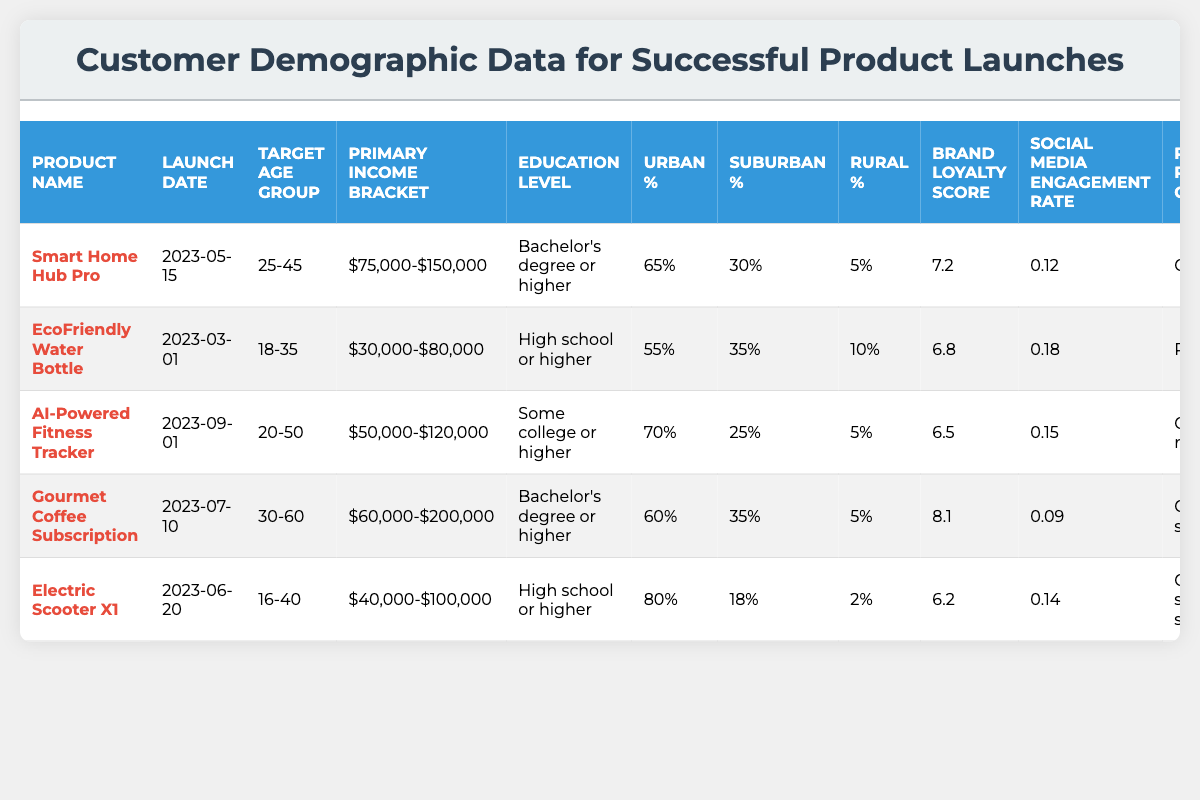What is the target age group for the "Gourmet Coffee Subscription"? The table indicates that the target age group for the "Gourmet Coffee Subscription" is 30-60 years.
Answer: 30-60 Which product has the highest customer lifetime value? By comparing the customer lifetime values listed in the table, the "Gourmet Coffee Subscription" has the highest value at $3200.
Answer: $3200 What is the urban percentage for the "Smart Home Hub Pro"? The table shows that the urban percentage for the "Smart Home Hub Pro" is 65%.
Answer: 65% Is the repeat purchase rate for the "Electric Scooter X1" greater than 0.6? The repeat purchase rate for the "Electric Scooter X1" is 0.55, which is less than 0.6, making the statement false.
Answer: No Calculate the average brand loyalty score for all products. Adding the brand loyalty scores (7.2 + 6.8 + 6.5 + 8.1 + 6.2 = 34.8) and dividing by the number of products (5), the average brand loyalty score is 34.8/5 = 6.96.
Answer: 6.96 What is the preferred purchase channel for the "EcoFriendly Water Bottle"? The table identifies that the preferred purchase channel for the "EcoFriendly Water Bottle" is retail stores.
Answer: Retail stores Which product was launched the earliest and how does its target income bracket compare with others? The "EcoFriendly Water Bottle" was launched on 2023-03-01, with a primary income bracket of $30,000-$80,000. Comparing it with others, its income bracket is the lowest, particularly when looking at the "Gourmet Coffee Subscription" which has a bracket of $60,000-$200,000.
Answer: EcoFriendly Water Bottle; lowest How do the social media engagement rates compare for "AI-Powered Fitness Tracker" and "Gourmet Coffee Subscription"? The social media engagement rate for the "AI-Powered Fitness Tracker" is 0.15, while for the "Gourmet Coffee Subscription" it is 0.09. Thus, the engagement rate for the "AI-Powered Fitness Tracker" is higher.
Answer: AI-Powered Fitness Tracker is higher What percentage of customers for the "Electric Scooter X1" are urban? The table specifies that 80% of customers for the "Electric Scooter X1" are urban.
Answer: 80% If you were to rank the products by their environmental consciousness scores, where would the "EcoFriendly Water Bottle" place? The environmental consciousness score for the "EcoFriendly Water Bottle" is 9.2, which is the highest among the listed products (the next highest being the "Electric Scooter X1" with 8.8). Therefore, it ranks first.
Answer: First 